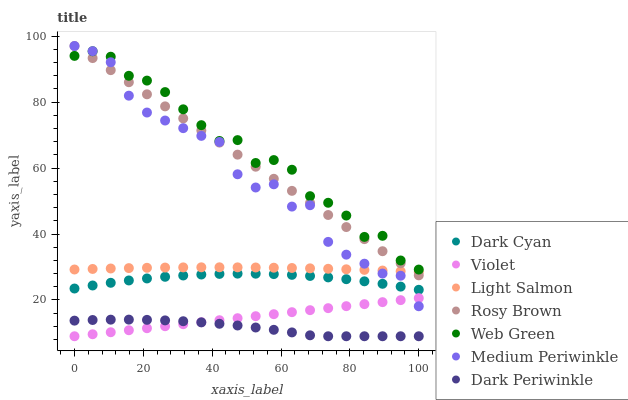Does Dark Periwinkle have the minimum area under the curve?
Answer yes or no. Yes. Does Web Green have the maximum area under the curve?
Answer yes or no. Yes. Does Rosy Brown have the minimum area under the curve?
Answer yes or no. No. Does Rosy Brown have the maximum area under the curve?
Answer yes or no. No. Is Violet the smoothest?
Answer yes or no. Yes. Is Medium Periwinkle the roughest?
Answer yes or no. Yes. Is Rosy Brown the smoothest?
Answer yes or no. No. Is Rosy Brown the roughest?
Answer yes or no. No. Does Violet have the lowest value?
Answer yes or no. Yes. Does Rosy Brown have the lowest value?
Answer yes or no. No. Does Medium Periwinkle have the highest value?
Answer yes or no. Yes. Does Web Green have the highest value?
Answer yes or no. No. Is Violet less than Rosy Brown?
Answer yes or no. Yes. Is Medium Periwinkle greater than Dark Periwinkle?
Answer yes or no. Yes. Does Web Green intersect Medium Periwinkle?
Answer yes or no. Yes. Is Web Green less than Medium Periwinkle?
Answer yes or no. No. Is Web Green greater than Medium Periwinkle?
Answer yes or no. No. Does Violet intersect Rosy Brown?
Answer yes or no. No. 